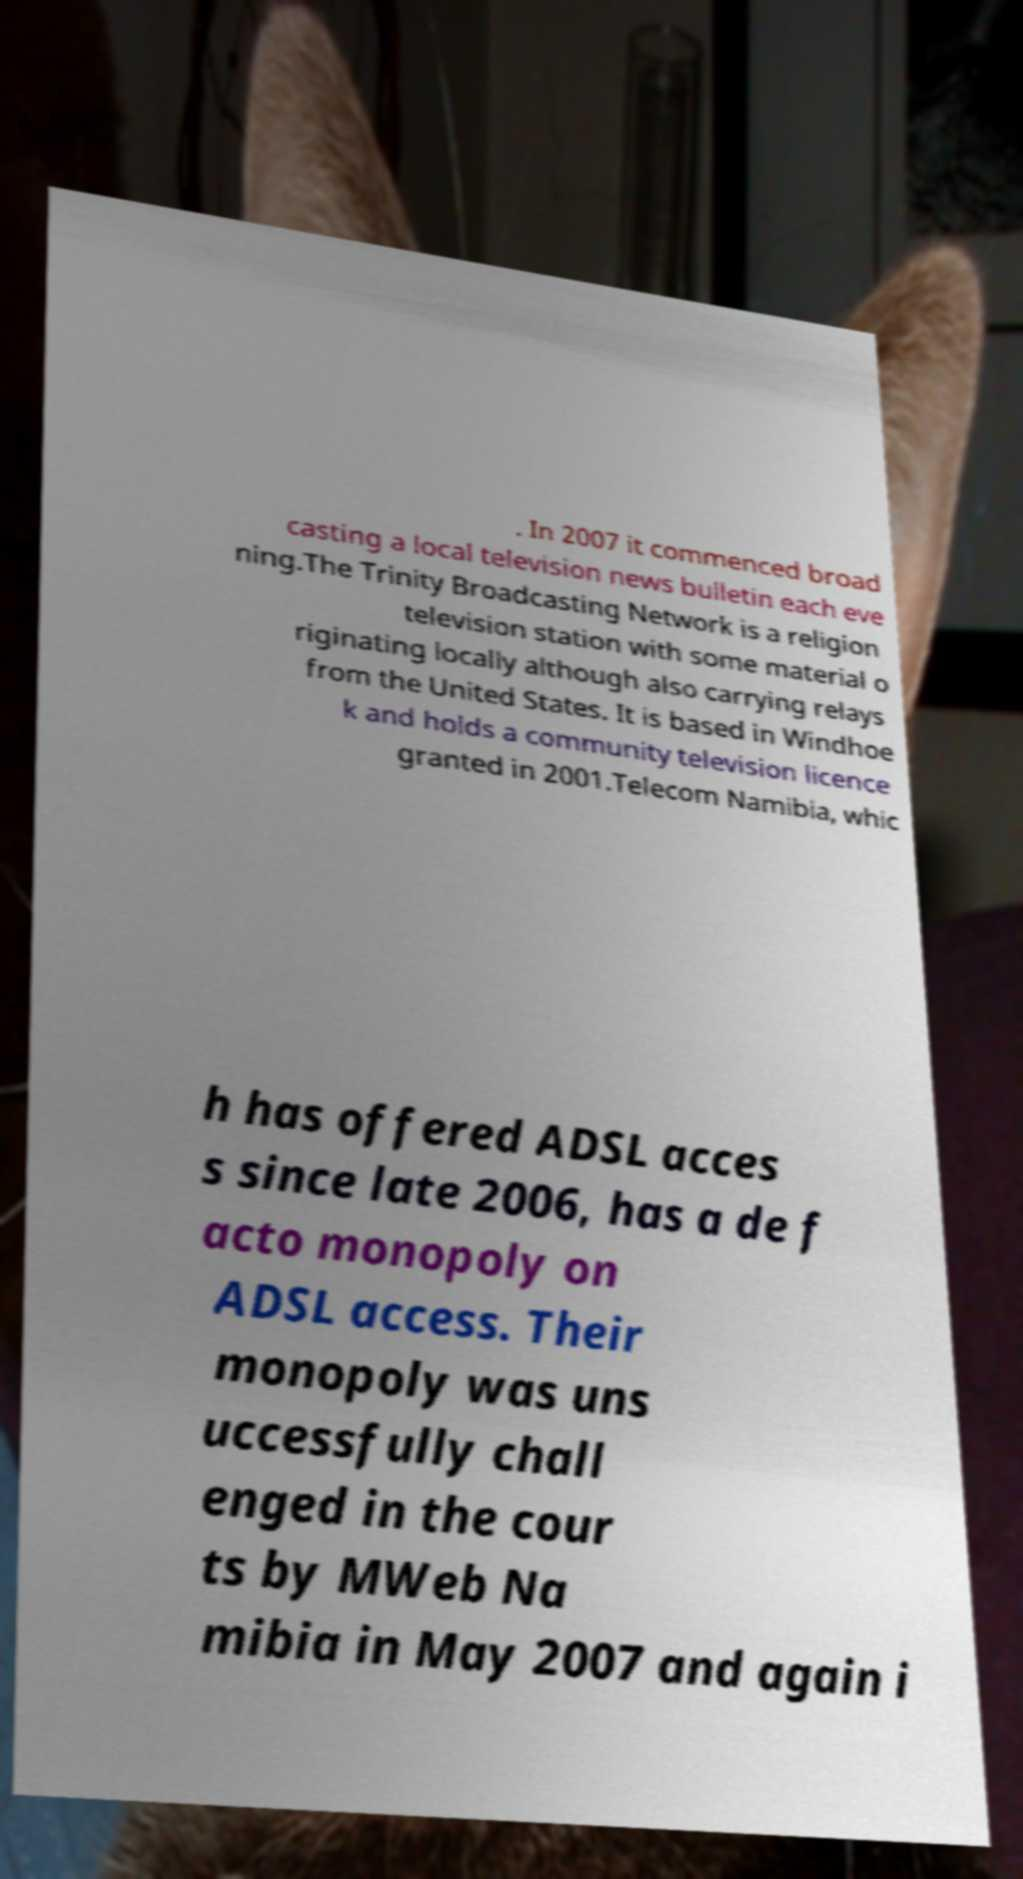Can you accurately transcribe the text from the provided image for me? . In 2007 it commenced broad casting a local television news bulletin each eve ning.The Trinity Broadcasting Network is a religion television station with some material o riginating locally although also carrying relays from the United States. It is based in Windhoe k and holds a community television licence granted in 2001.Telecom Namibia, whic h has offered ADSL acces s since late 2006, has a de f acto monopoly on ADSL access. Their monopoly was uns uccessfully chall enged in the cour ts by MWeb Na mibia in May 2007 and again i 